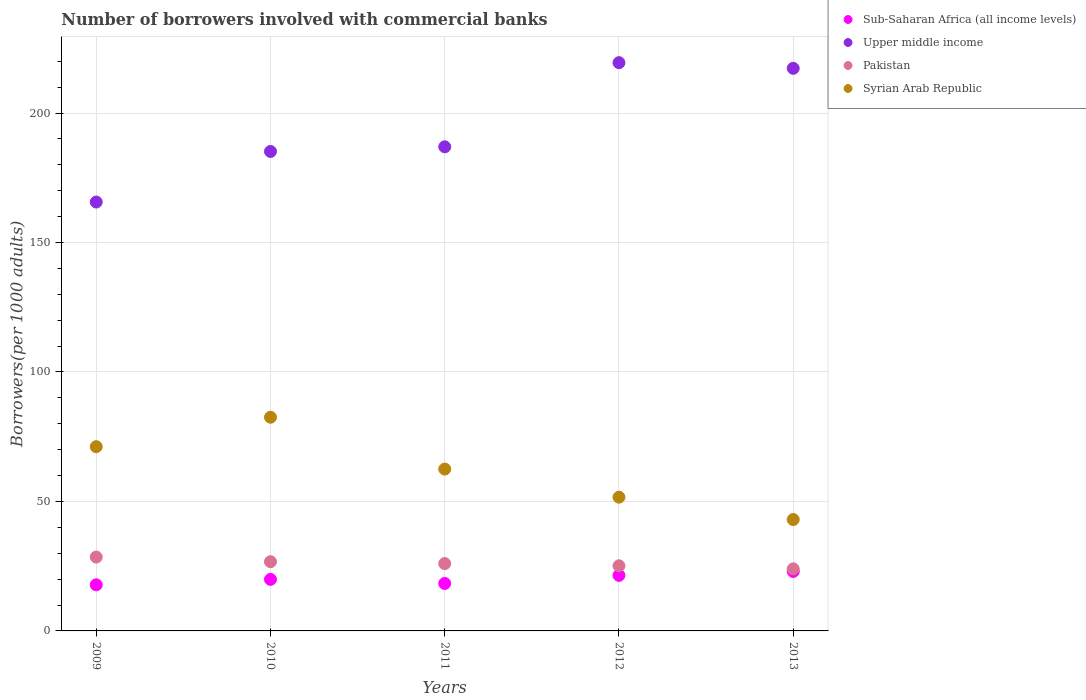Is the number of dotlines equal to the number of legend labels?
Provide a succinct answer. Yes. What is the number of borrowers involved with commercial banks in Upper middle income in 2011?
Give a very brief answer. 186.95. Across all years, what is the maximum number of borrowers involved with commercial banks in Sub-Saharan Africa (all income levels)?
Your response must be concise. 22.96. Across all years, what is the minimum number of borrowers involved with commercial banks in Syrian Arab Republic?
Offer a very short reply. 43.01. In which year was the number of borrowers involved with commercial banks in Pakistan maximum?
Make the answer very short. 2009. In which year was the number of borrowers involved with commercial banks in Pakistan minimum?
Provide a short and direct response. 2013. What is the total number of borrowers involved with commercial banks in Syrian Arab Republic in the graph?
Provide a succinct answer. 310.82. What is the difference between the number of borrowers involved with commercial banks in Pakistan in 2010 and that in 2011?
Provide a short and direct response. 0.72. What is the difference between the number of borrowers involved with commercial banks in Syrian Arab Republic in 2011 and the number of borrowers involved with commercial banks in Pakistan in 2009?
Offer a very short reply. 33.98. What is the average number of borrowers involved with commercial banks in Syrian Arab Republic per year?
Keep it short and to the point. 62.16. In the year 2009, what is the difference between the number of borrowers involved with commercial banks in Sub-Saharan Africa (all income levels) and number of borrowers involved with commercial banks in Syrian Arab Republic?
Your answer should be very brief. -53.34. In how many years, is the number of borrowers involved with commercial banks in Syrian Arab Republic greater than 140?
Provide a short and direct response. 0. What is the ratio of the number of borrowers involved with commercial banks in Sub-Saharan Africa (all income levels) in 2012 to that in 2013?
Provide a short and direct response. 0.93. Is the difference between the number of borrowers involved with commercial banks in Sub-Saharan Africa (all income levels) in 2010 and 2011 greater than the difference between the number of borrowers involved with commercial banks in Syrian Arab Republic in 2010 and 2011?
Offer a terse response. No. What is the difference between the highest and the second highest number of borrowers involved with commercial banks in Syrian Arab Republic?
Provide a succinct answer. 11.37. What is the difference between the highest and the lowest number of borrowers involved with commercial banks in Syrian Arab Republic?
Ensure brevity in your answer.  39.51. In how many years, is the number of borrowers involved with commercial banks in Syrian Arab Republic greater than the average number of borrowers involved with commercial banks in Syrian Arab Republic taken over all years?
Give a very brief answer. 3. Is it the case that in every year, the sum of the number of borrowers involved with commercial banks in Upper middle income and number of borrowers involved with commercial banks in Pakistan  is greater than the number of borrowers involved with commercial banks in Sub-Saharan Africa (all income levels)?
Offer a terse response. Yes. Does the graph contain any zero values?
Your answer should be compact. No. What is the title of the graph?
Keep it short and to the point. Number of borrowers involved with commercial banks. What is the label or title of the Y-axis?
Your answer should be very brief. Borrowers(per 1000 adults). What is the Borrowers(per 1000 adults) in Sub-Saharan Africa (all income levels) in 2009?
Offer a terse response. 17.81. What is the Borrowers(per 1000 adults) of Upper middle income in 2009?
Offer a terse response. 165.63. What is the Borrowers(per 1000 adults) in Pakistan in 2009?
Ensure brevity in your answer.  28.52. What is the Borrowers(per 1000 adults) in Syrian Arab Republic in 2009?
Provide a short and direct response. 71.15. What is the Borrowers(per 1000 adults) in Sub-Saharan Africa (all income levels) in 2010?
Your answer should be compact. 19.9. What is the Borrowers(per 1000 adults) of Upper middle income in 2010?
Keep it short and to the point. 185.15. What is the Borrowers(per 1000 adults) in Pakistan in 2010?
Your response must be concise. 26.73. What is the Borrowers(per 1000 adults) in Syrian Arab Republic in 2010?
Offer a terse response. 82.52. What is the Borrowers(per 1000 adults) of Sub-Saharan Africa (all income levels) in 2011?
Your answer should be compact. 18.33. What is the Borrowers(per 1000 adults) in Upper middle income in 2011?
Give a very brief answer. 186.95. What is the Borrowers(per 1000 adults) of Pakistan in 2011?
Keep it short and to the point. 26.01. What is the Borrowers(per 1000 adults) of Syrian Arab Republic in 2011?
Ensure brevity in your answer.  62.5. What is the Borrowers(per 1000 adults) of Sub-Saharan Africa (all income levels) in 2012?
Provide a short and direct response. 21.46. What is the Borrowers(per 1000 adults) in Upper middle income in 2012?
Ensure brevity in your answer.  219.44. What is the Borrowers(per 1000 adults) in Pakistan in 2012?
Provide a succinct answer. 25.15. What is the Borrowers(per 1000 adults) of Syrian Arab Republic in 2012?
Your answer should be compact. 51.65. What is the Borrowers(per 1000 adults) in Sub-Saharan Africa (all income levels) in 2013?
Make the answer very short. 22.96. What is the Borrowers(per 1000 adults) of Upper middle income in 2013?
Provide a short and direct response. 217.26. What is the Borrowers(per 1000 adults) in Pakistan in 2013?
Your answer should be compact. 23.97. What is the Borrowers(per 1000 adults) of Syrian Arab Republic in 2013?
Your answer should be compact. 43.01. Across all years, what is the maximum Borrowers(per 1000 adults) in Sub-Saharan Africa (all income levels)?
Offer a very short reply. 22.96. Across all years, what is the maximum Borrowers(per 1000 adults) of Upper middle income?
Your response must be concise. 219.44. Across all years, what is the maximum Borrowers(per 1000 adults) in Pakistan?
Your response must be concise. 28.52. Across all years, what is the maximum Borrowers(per 1000 adults) of Syrian Arab Republic?
Ensure brevity in your answer.  82.52. Across all years, what is the minimum Borrowers(per 1000 adults) in Sub-Saharan Africa (all income levels)?
Ensure brevity in your answer.  17.81. Across all years, what is the minimum Borrowers(per 1000 adults) of Upper middle income?
Make the answer very short. 165.63. Across all years, what is the minimum Borrowers(per 1000 adults) in Pakistan?
Provide a succinct answer. 23.97. Across all years, what is the minimum Borrowers(per 1000 adults) of Syrian Arab Republic?
Give a very brief answer. 43.01. What is the total Borrowers(per 1000 adults) in Sub-Saharan Africa (all income levels) in the graph?
Give a very brief answer. 100.46. What is the total Borrowers(per 1000 adults) in Upper middle income in the graph?
Offer a terse response. 974.43. What is the total Borrowers(per 1000 adults) in Pakistan in the graph?
Your answer should be compact. 130.37. What is the total Borrowers(per 1000 adults) in Syrian Arab Republic in the graph?
Provide a succinct answer. 310.82. What is the difference between the Borrowers(per 1000 adults) in Sub-Saharan Africa (all income levels) in 2009 and that in 2010?
Provide a short and direct response. -2.1. What is the difference between the Borrowers(per 1000 adults) of Upper middle income in 2009 and that in 2010?
Your answer should be compact. -19.53. What is the difference between the Borrowers(per 1000 adults) in Pakistan in 2009 and that in 2010?
Your response must be concise. 1.79. What is the difference between the Borrowers(per 1000 adults) of Syrian Arab Republic in 2009 and that in 2010?
Offer a terse response. -11.37. What is the difference between the Borrowers(per 1000 adults) of Sub-Saharan Africa (all income levels) in 2009 and that in 2011?
Make the answer very short. -0.53. What is the difference between the Borrowers(per 1000 adults) in Upper middle income in 2009 and that in 2011?
Provide a succinct answer. -21.33. What is the difference between the Borrowers(per 1000 adults) in Pakistan in 2009 and that in 2011?
Your answer should be very brief. 2.51. What is the difference between the Borrowers(per 1000 adults) in Syrian Arab Republic in 2009 and that in 2011?
Give a very brief answer. 8.65. What is the difference between the Borrowers(per 1000 adults) in Sub-Saharan Africa (all income levels) in 2009 and that in 2012?
Your answer should be compact. -3.65. What is the difference between the Borrowers(per 1000 adults) in Upper middle income in 2009 and that in 2012?
Provide a succinct answer. -53.81. What is the difference between the Borrowers(per 1000 adults) in Pakistan in 2009 and that in 2012?
Ensure brevity in your answer.  3.37. What is the difference between the Borrowers(per 1000 adults) in Syrian Arab Republic in 2009 and that in 2012?
Ensure brevity in your answer.  19.5. What is the difference between the Borrowers(per 1000 adults) of Sub-Saharan Africa (all income levels) in 2009 and that in 2013?
Offer a terse response. -5.16. What is the difference between the Borrowers(per 1000 adults) of Upper middle income in 2009 and that in 2013?
Your answer should be very brief. -51.63. What is the difference between the Borrowers(per 1000 adults) in Pakistan in 2009 and that in 2013?
Provide a short and direct response. 4.55. What is the difference between the Borrowers(per 1000 adults) in Syrian Arab Republic in 2009 and that in 2013?
Offer a terse response. 28.13. What is the difference between the Borrowers(per 1000 adults) in Sub-Saharan Africa (all income levels) in 2010 and that in 2011?
Offer a terse response. 1.57. What is the difference between the Borrowers(per 1000 adults) of Upper middle income in 2010 and that in 2011?
Give a very brief answer. -1.8. What is the difference between the Borrowers(per 1000 adults) of Pakistan in 2010 and that in 2011?
Offer a terse response. 0.72. What is the difference between the Borrowers(per 1000 adults) of Syrian Arab Republic in 2010 and that in 2011?
Your answer should be compact. 20.02. What is the difference between the Borrowers(per 1000 adults) of Sub-Saharan Africa (all income levels) in 2010 and that in 2012?
Ensure brevity in your answer.  -1.56. What is the difference between the Borrowers(per 1000 adults) of Upper middle income in 2010 and that in 2012?
Offer a terse response. -34.28. What is the difference between the Borrowers(per 1000 adults) in Pakistan in 2010 and that in 2012?
Give a very brief answer. 1.58. What is the difference between the Borrowers(per 1000 adults) of Syrian Arab Republic in 2010 and that in 2012?
Give a very brief answer. 30.87. What is the difference between the Borrowers(per 1000 adults) in Sub-Saharan Africa (all income levels) in 2010 and that in 2013?
Your response must be concise. -3.06. What is the difference between the Borrowers(per 1000 adults) in Upper middle income in 2010 and that in 2013?
Keep it short and to the point. -32.1. What is the difference between the Borrowers(per 1000 adults) in Pakistan in 2010 and that in 2013?
Offer a terse response. 2.76. What is the difference between the Borrowers(per 1000 adults) in Syrian Arab Republic in 2010 and that in 2013?
Ensure brevity in your answer.  39.51. What is the difference between the Borrowers(per 1000 adults) in Sub-Saharan Africa (all income levels) in 2011 and that in 2012?
Offer a terse response. -3.13. What is the difference between the Borrowers(per 1000 adults) in Upper middle income in 2011 and that in 2012?
Give a very brief answer. -32.48. What is the difference between the Borrowers(per 1000 adults) in Pakistan in 2011 and that in 2012?
Offer a terse response. 0.86. What is the difference between the Borrowers(per 1000 adults) of Syrian Arab Republic in 2011 and that in 2012?
Offer a terse response. 10.85. What is the difference between the Borrowers(per 1000 adults) in Sub-Saharan Africa (all income levels) in 2011 and that in 2013?
Your response must be concise. -4.63. What is the difference between the Borrowers(per 1000 adults) of Upper middle income in 2011 and that in 2013?
Your response must be concise. -30.3. What is the difference between the Borrowers(per 1000 adults) in Pakistan in 2011 and that in 2013?
Offer a very short reply. 2.04. What is the difference between the Borrowers(per 1000 adults) of Syrian Arab Republic in 2011 and that in 2013?
Your answer should be very brief. 19.49. What is the difference between the Borrowers(per 1000 adults) in Sub-Saharan Africa (all income levels) in 2012 and that in 2013?
Offer a very short reply. -1.5. What is the difference between the Borrowers(per 1000 adults) of Upper middle income in 2012 and that in 2013?
Your answer should be very brief. 2.18. What is the difference between the Borrowers(per 1000 adults) in Pakistan in 2012 and that in 2013?
Your response must be concise. 1.18. What is the difference between the Borrowers(per 1000 adults) of Syrian Arab Republic in 2012 and that in 2013?
Your answer should be very brief. 8.63. What is the difference between the Borrowers(per 1000 adults) of Sub-Saharan Africa (all income levels) in 2009 and the Borrowers(per 1000 adults) of Upper middle income in 2010?
Provide a short and direct response. -167.35. What is the difference between the Borrowers(per 1000 adults) in Sub-Saharan Africa (all income levels) in 2009 and the Borrowers(per 1000 adults) in Pakistan in 2010?
Your answer should be very brief. -8.92. What is the difference between the Borrowers(per 1000 adults) in Sub-Saharan Africa (all income levels) in 2009 and the Borrowers(per 1000 adults) in Syrian Arab Republic in 2010?
Ensure brevity in your answer.  -64.71. What is the difference between the Borrowers(per 1000 adults) in Upper middle income in 2009 and the Borrowers(per 1000 adults) in Pakistan in 2010?
Offer a terse response. 138.9. What is the difference between the Borrowers(per 1000 adults) of Upper middle income in 2009 and the Borrowers(per 1000 adults) of Syrian Arab Republic in 2010?
Your answer should be very brief. 83.11. What is the difference between the Borrowers(per 1000 adults) of Pakistan in 2009 and the Borrowers(per 1000 adults) of Syrian Arab Republic in 2010?
Give a very brief answer. -54. What is the difference between the Borrowers(per 1000 adults) of Sub-Saharan Africa (all income levels) in 2009 and the Borrowers(per 1000 adults) of Upper middle income in 2011?
Provide a succinct answer. -169.15. What is the difference between the Borrowers(per 1000 adults) of Sub-Saharan Africa (all income levels) in 2009 and the Borrowers(per 1000 adults) of Pakistan in 2011?
Make the answer very short. -8.2. What is the difference between the Borrowers(per 1000 adults) in Sub-Saharan Africa (all income levels) in 2009 and the Borrowers(per 1000 adults) in Syrian Arab Republic in 2011?
Ensure brevity in your answer.  -44.69. What is the difference between the Borrowers(per 1000 adults) in Upper middle income in 2009 and the Borrowers(per 1000 adults) in Pakistan in 2011?
Provide a short and direct response. 139.62. What is the difference between the Borrowers(per 1000 adults) of Upper middle income in 2009 and the Borrowers(per 1000 adults) of Syrian Arab Republic in 2011?
Keep it short and to the point. 103.13. What is the difference between the Borrowers(per 1000 adults) in Pakistan in 2009 and the Borrowers(per 1000 adults) in Syrian Arab Republic in 2011?
Keep it short and to the point. -33.98. What is the difference between the Borrowers(per 1000 adults) of Sub-Saharan Africa (all income levels) in 2009 and the Borrowers(per 1000 adults) of Upper middle income in 2012?
Offer a terse response. -201.63. What is the difference between the Borrowers(per 1000 adults) of Sub-Saharan Africa (all income levels) in 2009 and the Borrowers(per 1000 adults) of Pakistan in 2012?
Your response must be concise. -7.34. What is the difference between the Borrowers(per 1000 adults) of Sub-Saharan Africa (all income levels) in 2009 and the Borrowers(per 1000 adults) of Syrian Arab Republic in 2012?
Your answer should be very brief. -33.84. What is the difference between the Borrowers(per 1000 adults) in Upper middle income in 2009 and the Borrowers(per 1000 adults) in Pakistan in 2012?
Give a very brief answer. 140.48. What is the difference between the Borrowers(per 1000 adults) in Upper middle income in 2009 and the Borrowers(per 1000 adults) in Syrian Arab Republic in 2012?
Your answer should be compact. 113.98. What is the difference between the Borrowers(per 1000 adults) in Pakistan in 2009 and the Borrowers(per 1000 adults) in Syrian Arab Republic in 2012?
Your answer should be compact. -23.13. What is the difference between the Borrowers(per 1000 adults) of Sub-Saharan Africa (all income levels) in 2009 and the Borrowers(per 1000 adults) of Upper middle income in 2013?
Make the answer very short. -199.45. What is the difference between the Borrowers(per 1000 adults) of Sub-Saharan Africa (all income levels) in 2009 and the Borrowers(per 1000 adults) of Pakistan in 2013?
Give a very brief answer. -6.16. What is the difference between the Borrowers(per 1000 adults) in Sub-Saharan Africa (all income levels) in 2009 and the Borrowers(per 1000 adults) in Syrian Arab Republic in 2013?
Offer a very short reply. -25.21. What is the difference between the Borrowers(per 1000 adults) of Upper middle income in 2009 and the Borrowers(per 1000 adults) of Pakistan in 2013?
Provide a short and direct response. 141.66. What is the difference between the Borrowers(per 1000 adults) in Upper middle income in 2009 and the Borrowers(per 1000 adults) in Syrian Arab Republic in 2013?
Provide a succinct answer. 122.62. What is the difference between the Borrowers(per 1000 adults) of Pakistan in 2009 and the Borrowers(per 1000 adults) of Syrian Arab Republic in 2013?
Provide a short and direct response. -14.49. What is the difference between the Borrowers(per 1000 adults) in Sub-Saharan Africa (all income levels) in 2010 and the Borrowers(per 1000 adults) in Upper middle income in 2011?
Your answer should be compact. -167.05. What is the difference between the Borrowers(per 1000 adults) of Sub-Saharan Africa (all income levels) in 2010 and the Borrowers(per 1000 adults) of Pakistan in 2011?
Provide a short and direct response. -6.11. What is the difference between the Borrowers(per 1000 adults) of Sub-Saharan Africa (all income levels) in 2010 and the Borrowers(per 1000 adults) of Syrian Arab Republic in 2011?
Your answer should be compact. -42.59. What is the difference between the Borrowers(per 1000 adults) of Upper middle income in 2010 and the Borrowers(per 1000 adults) of Pakistan in 2011?
Your answer should be compact. 159.14. What is the difference between the Borrowers(per 1000 adults) of Upper middle income in 2010 and the Borrowers(per 1000 adults) of Syrian Arab Republic in 2011?
Your answer should be compact. 122.66. What is the difference between the Borrowers(per 1000 adults) of Pakistan in 2010 and the Borrowers(per 1000 adults) of Syrian Arab Republic in 2011?
Your response must be concise. -35.77. What is the difference between the Borrowers(per 1000 adults) in Sub-Saharan Africa (all income levels) in 2010 and the Borrowers(per 1000 adults) in Upper middle income in 2012?
Provide a short and direct response. -199.53. What is the difference between the Borrowers(per 1000 adults) of Sub-Saharan Africa (all income levels) in 2010 and the Borrowers(per 1000 adults) of Pakistan in 2012?
Offer a very short reply. -5.24. What is the difference between the Borrowers(per 1000 adults) of Sub-Saharan Africa (all income levels) in 2010 and the Borrowers(per 1000 adults) of Syrian Arab Republic in 2012?
Provide a succinct answer. -31.74. What is the difference between the Borrowers(per 1000 adults) of Upper middle income in 2010 and the Borrowers(per 1000 adults) of Pakistan in 2012?
Your response must be concise. 160.01. What is the difference between the Borrowers(per 1000 adults) in Upper middle income in 2010 and the Borrowers(per 1000 adults) in Syrian Arab Republic in 2012?
Make the answer very short. 133.51. What is the difference between the Borrowers(per 1000 adults) of Pakistan in 2010 and the Borrowers(per 1000 adults) of Syrian Arab Republic in 2012?
Keep it short and to the point. -24.92. What is the difference between the Borrowers(per 1000 adults) in Sub-Saharan Africa (all income levels) in 2010 and the Borrowers(per 1000 adults) in Upper middle income in 2013?
Give a very brief answer. -197.35. What is the difference between the Borrowers(per 1000 adults) in Sub-Saharan Africa (all income levels) in 2010 and the Borrowers(per 1000 adults) in Pakistan in 2013?
Keep it short and to the point. -4.06. What is the difference between the Borrowers(per 1000 adults) of Sub-Saharan Africa (all income levels) in 2010 and the Borrowers(per 1000 adults) of Syrian Arab Republic in 2013?
Your answer should be very brief. -23.11. What is the difference between the Borrowers(per 1000 adults) of Upper middle income in 2010 and the Borrowers(per 1000 adults) of Pakistan in 2013?
Offer a very short reply. 161.19. What is the difference between the Borrowers(per 1000 adults) of Upper middle income in 2010 and the Borrowers(per 1000 adults) of Syrian Arab Republic in 2013?
Provide a short and direct response. 142.14. What is the difference between the Borrowers(per 1000 adults) of Pakistan in 2010 and the Borrowers(per 1000 adults) of Syrian Arab Republic in 2013?
Your answer should be compact. -16.28. What is the difference between the Borrowers(per 1000 adults) in Sub-Saharan Africa (all income levels) in 2011 and the Borrowers(per 1000 adults) in Upper middle income in 2012?
Offer a very short reply. -201.11. What is the difference between the Borrowers(per 1000 adults) in Sub-Saharan Africa (all income levels) in 2011 and the Borrowers(per 1000 adults) in Pakistan in 2012?
Offer a terse response. -6.82. What is the difference between the Borrowers(per 1000 adults) in Sub-Saharan Africa (all income levels) in 2011 and the Borrowers(per 1000 adults) in Syrian Arab Republic in 2012?
Provide a short and direct response. -33.31. What is the difference between the Borrowers(per 1000 adults) of Upper middle income in 2011 and the Borrowers(per 1000 adults) of Pakistan in 2012?
Offer a terse response. 161.81. What is the difference between the Borrowers(per 1000 adults) in Upper middle income in 2011 and the Borrowers(per 1000 adults) in Syrian Arab Republic in 2012?
Your answer should be very brief. 135.31. What is the difference between the Borrowers(per 1000 adults) in Pakistan in 2011 and the Borrowers(per 1000 adults) in Syrian Arab Republic in 2012?
Ensure brevity in your answer.  -25.64. What is the difference between the Borrowers(per 1000 adults) in Sub-Saharan Africa (all income levels) in 2011 and the Borrowers(per 1000 adults) in Upper middle income in 2013?
Keep it short and to the point. -198.92. What is the difference between the Borrowers(per 1000 adults) in Sub-Saharan Africa (all income levels) in 2011 and the Borrowers(per 1000 adults) in Pakistan in 2013?
Ensure brevity in your answer.  -5.63. What is the difference between the Borrowers(per 1000 adults) in Sub-Saharan Africa (all income levels) in 2011 and the Borrowers(per 1000 adults) in Syrian Arab Republic in 2013?
Your answer should be very brief. -24.68. What is the difference between the Borrowers(per 1000 adults) in Upper middle income in 2011 and the Borrowers(per 1000 adults) in Pakistan in 2013?
Provide a succinct answer. 162.99. What is the difference between the Borrowers(per 1000 adults) in Upper middle income in 2011 and the Borrowers(per 1000 adults) in Syrian Arab Republic in 2013?
Ensure brevity in your answer.  143.94. What is the difference between the Borrowers(per 1000 adults) in Pakistan in 2011 and the Borrowers(per 1000 adults) in Syrian Arab Republic in 2013?
Your answer should be compact. -17. What is the difference between the Borrowers(per 1000 adults) of Sub-Saharan Africa (all income levels) in 2012 and the Borrowers(per 1000 adults) of Upper middle income in 2013?
Your response must be concise. -195.8. What is the difference between the Borrowers(per 1000 adults) in Sub-Saharan Africa (all income levels) in 2012 and the Borrowers(per 1000 adults) in Pakistan in 2013?
Your answer should be very brief. -2.51. What is the difference between the Borrowers(per 1000 adults) of Sub-Saharan Africa (all income levels) in 2012 and the Borrowers(per 1000 adults) of Syrian Arab Republic in 2013?
Give a very brief answer. -21.55. What is the difference between the Borrowers(per 1000 adults) of Upper middle income in 2012 and the Borrowers(per 1000 adults) of Pakistan in 2013?
Offer a very short reply. 195.47. What is the difference between the Borrowers(per 1000 adults) in Upper middle income in 2012 and the Borrowers(per 1000 adults) in Syrian Arab Republic in 2013?
Your response must be concise. 176.43. What is the difference between the Borrowers(per 1000 adults) of Pakistan in 2012 and the Borrowers(per 1000 adults) of Syrian Arab Republic in 2013?
Provide a succinct answer. -17.86. What is the average Borrowers(per 1000 adults) in Sub-Saharan Africa (all income levels) per year?
Give a very brief answer. 20.09. What is the average Borrowers(per 1000 adults) of Upper middle income per year?
Keep it short and to the point. 194.89. What is the average Borrowers(per 1000 adults) of Pakistan per year?
Make the answer very short. 26.07. What is the average Borrowers(per 1000 adults) of Syrian Arab Republic per year?
Offer a very short reply. 62.16. In the year 2009, what is the difference between the Borrowers(per 1000 adults) in Sub-Saharan Africa (all income levels) and Borrowers(per 1000 adults) in Upper middle income?
Provide a succinct answer. -147.82. In the year 2009, what is the difference between the Borrowers(per 1000 adults) in Sub-Saharan Africa (all income levels) and Borrowers(per 1000 adults) in Pakistan?
Give a very brief answer. -10.72. In the year 2009, what is the difference between the Borrowers(per 1000 adults) of Sub-Saharan Africa (all income levels) and Borrowers(per 1000 adults) of Syrian Arab Republic?
Offer a very short reply. -53.34. In the year 2009, what is the difference between the Borrowers(per 1000 adults) of Upper middle income and Borrowers(per 1000 adults) of Pakistan?
Make the answer very short. 137.11. In the year 2009, what is the difference between the Borrowers(per 1000 adults) of Upper middle income and Borrowers(per 1000 adults) of Syrian Arab Republic?
Your answer should be very brief. 94.48. In the year 2009, what is the difference between the Borrowers(per 1000 adults) in Pakistan and Borrowers(per 1000 adults) in Syrian Arab Republic?
Provide a succinct answer. -42.62. In the year 2010, what is the difference between the Borrowers(per 1000 adults) in Sub-Saharan Africa (all income levels) and Borrowers(per 1000 adults) in Upper middle income?
Your answer should be very brief. -165.25. In the year 2010, what is the difference between the Borrowers(per 1000 adults) in Sub-Saharan Africa (all income levels) and Borrowers(per 1000 adults) in Pakistan?
Ensure brevity in your answer.  -6.83. In the year 2010, what is the difference between the Borrowers(per 1000 adults) of Sub-Saharan Africa (all income levels) and Borrowers(per 1000 adults) of Syrian Arab Republic?
Your answer should be compact. -62.61. In the year 2010, what is the difference between the Borrowers(per 1000 adults) in Upper middle income and Borrowers(per 1000 adults) in Pakistan?
Ensure brevity in your answer.  158.42. In the year 2010, what is the difference between the Borrowers(per 1000 adults) of Upper middle income and Borrowers(per 1000 adults) of Syrian Arab Republic?
Offer a very short reply. 102.64. In the year 2010, what is the difference between the Borrowers(per 1000 adults) of Pakistan and Borrowers(per 1000 adults) of Syrian Arab Republic?
Your response must be concise. -55.79. In the year 2011, what is the difference between the Borrowers(per 1000 adults) in Sub-Saharan Africa (all income levels) and Borrowers(per 1000 adults) in Upper middle income?
Ensure brevity in your answer.  -168.62. In the year 2011, what is the difference between the Borrowers(per 1000 adults) of Sub-Saharan Africa (all income levels) and Borrowers(per 1000 adults) of Pakistan?
Offer a very short reply. -7.68. In the year 2011, what is the difference between the Borrowers(per 1000 adults) in Sub-Saharan Africa (all income levels) and Borrowers(per 1000 adults) in Syrian Arab Republic?
Offer a terse response. -44.17. In the year 2011, what is the difference between the Borrowers(per 1000 adults) in Upper middle income and Borrowers(per 1000 adults) in Pakistan?
Make the answer very short. 160.95. In the year 2011, what is the difference between the Borrowers(per 1000 adults) of Upper middle income and Borrowers(per 1000 adults) of Syrian Arab Republic?
Offer a terse response. 124.46. In the year 2011, what is the difference between the Borrowers(per 1000 adults) of Pakistan and Borrowers(per 1000 adults) of Syrian Arab Republic?
Provide a short and direct response. -36.49. In the year 2012, what is the difference between the Borrowers(per 1000 adults) of Sub-Saharan Africa (all income levels) and Borrowers(per 1000 adults) of Upper middle income?
Provide a succinct answer. -197.98. In the year 2012, what is the difference between the Borrowers(per 1000 adults) of Sub-Saharan Africa (all income levels) and Borrowers(per 1000 adults) of Pakistan?
Give a very brief answer. -3.69. In the year 2012, what is the difference between the Borrowers(per 1000 adults) of Sub-Saharan Africa (all income levels) and Borrowers(per 1000 adults) of Syrian Arab Republic?
Keep it short and to the point. -30.19. In the year 2012, what is the difference between the Borrowers(per 1000 adults) in Upper middle income and Borrowers(per 1000 adults) in Pakistan?
Provide a succinct answer. 194.29. In the year 2012, what is the difference between the Borrowers(per 1000 adults) in Upper middle income and Borrowers(per 1000 adults) in Syrian Arab Republic?
Your answer should be very brief. 167.79. In the year 2012, what is the difference between the Borrowers(per 1000 adults) in Pakistan and Borrowers(per 1000 adults) in Syrian Arab Republic?
Offer a terse response. -26.5. In the year 2013, what is the difference between the Borrowers(per 1000 adults) of Sub-Saharan Africa (all income levels) and Borrowers(per 1000 adults) of Upper middle income?
Keep it short and to the point. -194.29. In the year 2013, what is the difference between the Borrowers(per 1000 adults) of Sub-Saharan Africa (all income levels) and Borrowers(per 1000 adults) of Pakistan?
Your answer should be very brief. -1. In the year 2013, what is the difference between the Borrowers(per 1000 adults) of Sub-Saharan Africa (all income levels) and Borrowers(per 1000 adults) of Syrian Arab Republic?
Provide a short and direct response. -20.05. In the year 2013, what is the difference between the Borrowers(per 1000 adults) of Upper middle income and Borrowers(per 1000 adults) of Pakistan?
Give a very brief answer. 193.29. In the year 2013, what is the difference between the Borrowers(per 1000 adults) in Upper middle income and Borrowers(per 1000 adults) in Syrian Arab Republic?
Offer a very short reply. 174.24. In the year 2013, what is the difference between the Borrowers(per 1000 adults) of Pakistan and Borrowers(per 1000 adults) of Syrian Arab Republic?
Offer a terse response. -19.05. What is the ratio of the Borrowers(per 1000 adults) of Sub-Saharan Africa (all income levels) in 2009 to that in 2010?
Provide a short and direct response. 0.89. What is the ratio of the Borrowers(per 1000 adults) in Upper middle income in 2009 to that in 2010?
Keep it short and to the point. 0.89. What is the ratio of the Borrowers(per 1000 adults) of Pakistan in 2009 to that in 2010?
Provide a succinct answer. 1.07. What is the ratio of the Borrowers(per 1000 adults) in Syrian Arab Republic in 2009 to that in 2010?
Give a very brief answer. 0.86. What is the ratio of the Borrowers(per 1000 adults) in Sub-Saharan Africa (all income levels) in 2009 to that in 2011?
Your answer should be compact. 0.97. What is the ratio of the Borrowers(per 1000 adults) of Upper middle income in 2009 to that in 2011?
Offer a terse response. 0.89. What is the ratio of the Borrowers(per 1000 adults) in Pakistan in 2009 to that in 2011?
Provide a succinct answer. 1.1. What is the ratio of the Borrowers(per 1000 adults) in Syrian Arab Republic in 2009 to that in 2011?
Offer a terse response. 1.14. What is the ratio of the Borrowers(per 1000 adults) in Sub-Saharan Africa (all income levels) in 2009 to that in 2012?
Provide a short and direct response. 0.83. What is the ratio of the Borrowers(per 1000 adults) in Upper middle income in 2009 to that in 2012?
Your answer should be compact. 0.75. What is the ratio of the Borrowers(per 1000 adults) of Pakistan in 2009 to that in 2012?
Provide a succinct answer. 1.13. What is the ratio of the Borrowers(per 1000 adults) in Syrian Arab Republic in 2009 to that in 2012?
Make the answer very short. 1.38. What is the ratio of the Borrowers(per 1000 adults) in Sub-Saharan Africa (all income levels) in 2009 to that in 2013?
Offer a terse response. 0.78. What is the ratio of the Borrowers(per 1000 adults) in Upper middle income in 2009 to that in 2013?
Give a very brief answer. 0.76. What is the ratio of the Borrowers(per 1000 adults) in Pakistan in 2009 to that in 2013?
Ensure brevity in your answer.  1.19. What is the ratio of the Borrowers(per 1000 adults) in Syrian Arab Republic in 2009 to that in 2013?
Ensure brevity in your answer.  1.65. What is the ratio of the Borrowers(per 1000 adults) of Sub-Saharan Africa (all income levels) in 2010 to that in 2011?
Your answer should be very brief. 1.09. What is the ratio of the Borrowers(per 1000 adults) of Pakistan in 2010 to that in 2011?
Keep it short and to the point. 1.03. What is the ratio of the Borrowers(per 1000 adults) of Syrian Arab Republic in 2010 to that in 2011?
Make the answer very short. 1.32. What is the ratio of the Borrowers(per 1000 adults) in Sub-Saharan Africa (all income levels) in 2010 to that in 2012?
Offer a terse response. 0.93. What is the ratio of the Borrowers(per 1000 adults) of Upper middle income in 2010 to that in 2012?
Keep it short and to the point. 0.84. What is the ratio of the Borrowers(per 1000 adults) of Pakistan in 2010 to that in 2012?
Give a very brief answer. 1.06. What is the ratio of the Borrowers(per 1000 adults) of Syrian Arab Republic in 2010 to that in 2012?
Offer a very short reply. 1.6. What is the ratio of the Borrowers(per 1000 adults) of Sub-Saharan Africa (all income levels) in 2010 to that in 2013?
Keep it short and to the point. 0.87. What is the ratio of the Borrowers(per 1000 adults) in Upper middle income in 2010 to that in 2013?
Offer a terse response. 0.85. What is the ratio of the Borrowers(per 1000 adults) in Pakistan in 2010 to that in 2013?
Give a very brief answer. 1.12. What is the ratio of the Borrowers(per 1000 adults) in Syrian Arab Republic in 2010 to that in 2013?
Your answer should be very brief. 1.92. What is the ratio of the Borrowers(per 1000 adults) in Sub-Saharan Africa (all income levels) in 2011 to that in 2012?
Offer a very short reply. 0.85. What is the ratio of the Borrowers(per 1000 adults) in Upper middle income in 2011 to that in 2012?
Your answer should be very brief. 0.85. What is the ratio of the Borrowers(per 1000 adults) in Pakistan in 2011 to that in 2012?
Offer a very short reply. 1.03. What is the ratio of the Borrowers(per 1000 adults) in Syrian Arab Republic in 2011 to that in 2012?
Give a very brief answer. 1.21. What is the ratio of the Borrowers(per 1000 adults) of Sub-Saharan Africa (all income levels) in 2011 to that in 2013?
Ensure brevity in your answer.  0.8. What is the ratio of the Borrowers(per 1000 adults) in Upper middle income in 2011 to that in 2013?
Make the answer very short. 0.86. What is the ratio of the Borrowers(per 1000 adults) in Pakistan in 2011 to that in 2013?
Offer a very short reply. 1.09. What is the ratio of the Borrowers(per 1000 adults) of Syrian Arab Republic in 2011 to that in 2013?
Make the answer very short. 1.45. What is the ratio of the Borrowers(per 1000 adults) of Sub-Saharan Africa (all income levels) in 2012 to that in 2013?
Provide a succinct answer. 0.93. What is the ratio of the Borrowers(per 1000 adults) in Pakistan in 2012 to that in 2013?
Provide a short and direct response. 1.05. What is the ratio of the Borrowers(per 1000 adults) in Syrian Arab Republic in 2012 to that in 2013?
Provide a succinct answer. 1.2. What is the difference between the highest and the second highest Borrowers(per 1000 adults) of Sub-Saharan Africa (all income levels)?
Offer a very short reply. 1.5. What is the difference between the highest and the second highest Borrowers(per 1000 adults) in Upper middle income?
Offer a terse response. 2.18. What is the difference between the highest and the second highest Borrowers(per 1000 adults) in Pakistan?
Keep it short and to the point. 1.79. What is the difference between the highest and the second highest Borrowers(per 1000 adults) in Syrian Arab Republic?
Offer a terse response. 11.37. What is the difference between the highest and the lowest Borrowers(per 1000 adults) of Sub-Saharan Africa (all income levels)?
Ensure brevity in your answer.  5.16. What is the difference between the highest and the lowest Borrowers(per 1000 adults) of Upper middle income?
Provide a short and direct response. 53.81. What is the difference between the highest and the lowest Borrowers(per 1000 adults) of Pakistan?
Offer a terse response. 4.55. What is the difference between the highest and the lowest Borrowers(per 1000 adults) of Syrian Arab Republic?
Your answer should be very brief. 39.51. 